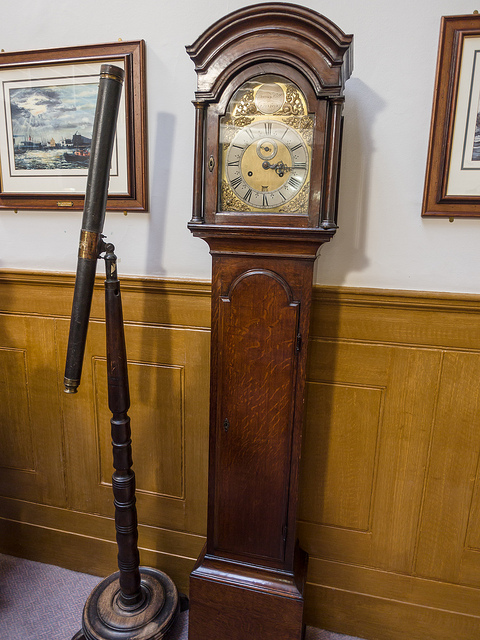<image>What are these tools? I am not sure. These tools can be a telescope and clock or other time measurement tools. What are these tools? I am not sure what these tools are. They can be time measurement tools or a telescope. 